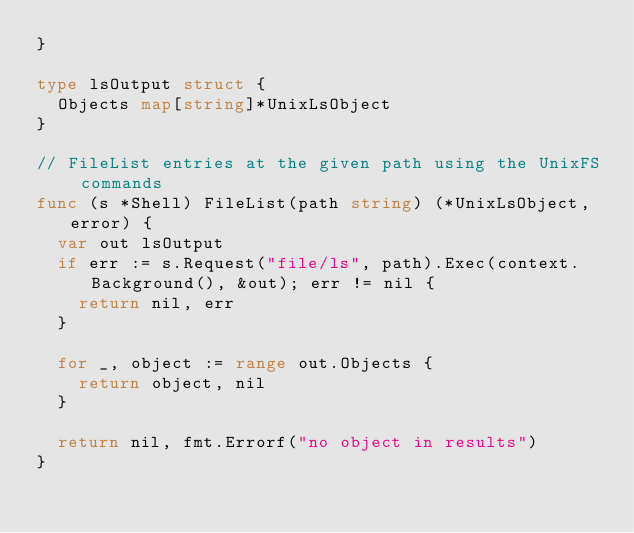<code> <loc_0><loc_0><loc_500><loc_500><_Go_>}

type lsOutput struct {
	Objects map[string]*UnixLsObject
}

// FileList entries at the given path using the UnixFS commands
func (s *Shell) FileList(path string) (*UnixLsObject, error) {
	var out lsOutput
	if err := s.Request("file/ls", path).Exec(context.Background(), &out); err != nil {
		return nil, err
	}

	for _, object := range out.Objects {
		return object, nil
	}

	return nil, fmt.Errorf("no object in results")
}
</code> 